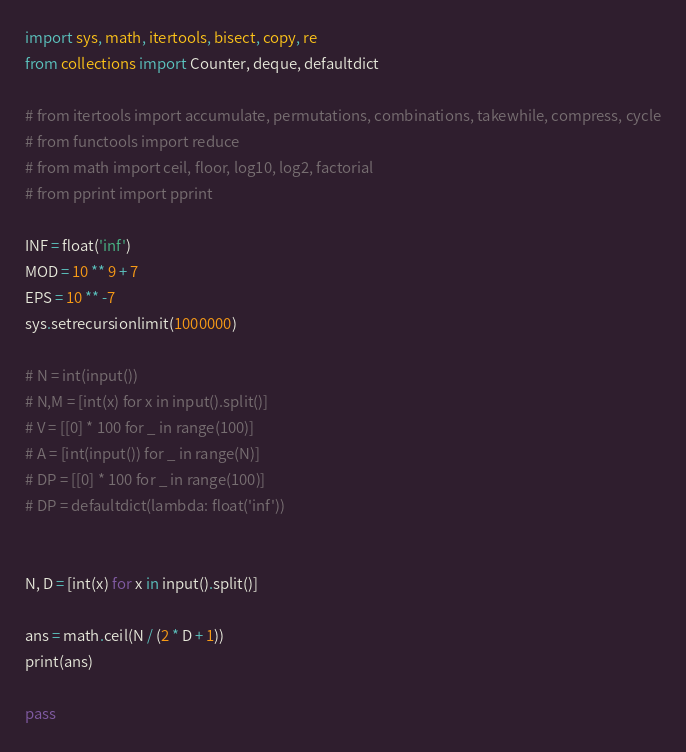Convert code to text. <code><loc_0><loc_0><loc_500><loc_500><_Python_>import sys, math, itertools, bisect, copy, re
from collections import Counter, deque, defaultdict

# from itertools import accumulate, permutations, combinations, takewhile, compress, cycle
# from functools import reduce
# from math import ceil, floor, log10, log2, factorial
# from pprint import pprint

INF = float('inf')
MOD = 10 ** 9 + 7
EPS = 10 ** -7
sys.setrecursionlimit(1000000)

# N = int(input())
# N,M = [int(x) for x in input().split()]
# V = [[0] * 100 for _ in range(100)]
# A = [int(input()) for _ in range(N)]
# DP = [[0] * 100 for _ in range(100)]
# DP = defaultdict(lambda: float('inf'))


N, D = [int(x) for x in input().split()]

ans = math.ceil(N / (2 * D + 1))
print(ans)

pass
</code> 